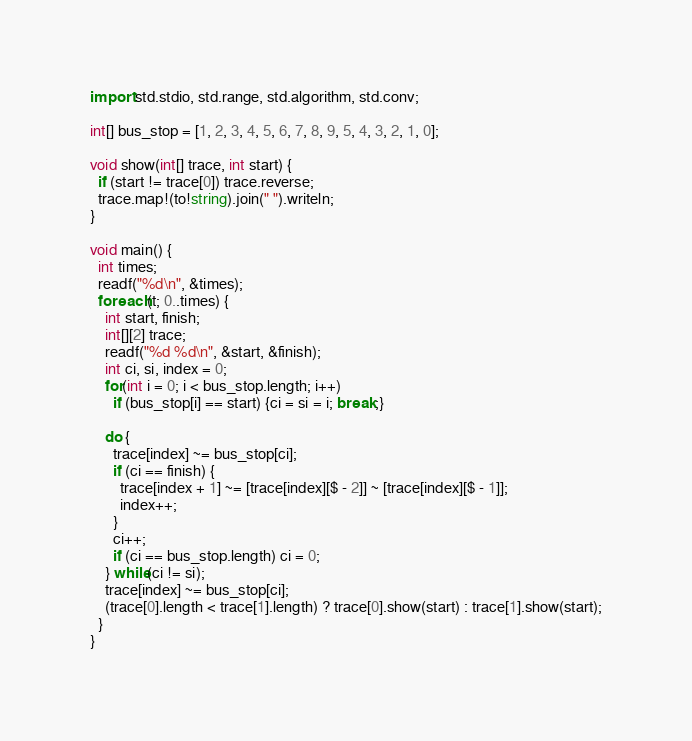Convert code to text. <code><loc_0><loc_0><loc_500><loc_500><_D_>
import std.stdio, std.range, std.algorithm, std.conv;

int[] bus_stop = [1, 2, 3, 4, 5, 6, 7, 8, 9, 5, 4, 3, 2, 1, 0];

void show(int[] trace, int start) {
  if (start != trace[0]) trace.reverse;
  trace.map!(to!string).join(" ").writeln;
}

void main() {
  int times;
  readf("%d\n", &times);
  foreach(t; 0..times) {
    int start, finish;
    int[][2] trace;
    readf("%d %d\n", &start, &finish);
    int ci, si, index = 0;
    for(int i = 0; i < bus_stop.length; i++)
      if (bus_stop[i] == start) {ci = si = i; break;}

    do {
      trace[index] ~= bus_stop[ci];
      if (ci == finish) {
        trace[index + 1] ~= [trace[index][$ - 2]] ~ [trace[index][$ - 1]];
        index++;
      }
      ci++;
      if (ci == bus_stop.length) ci = 0;
    } while(ci != si);
    trace[index] ~= bus_stop[ci];
    (trace[0].length < trace[1].length) ? trace[0].show(start) : trace[1].show(start);
  }
}</code> 